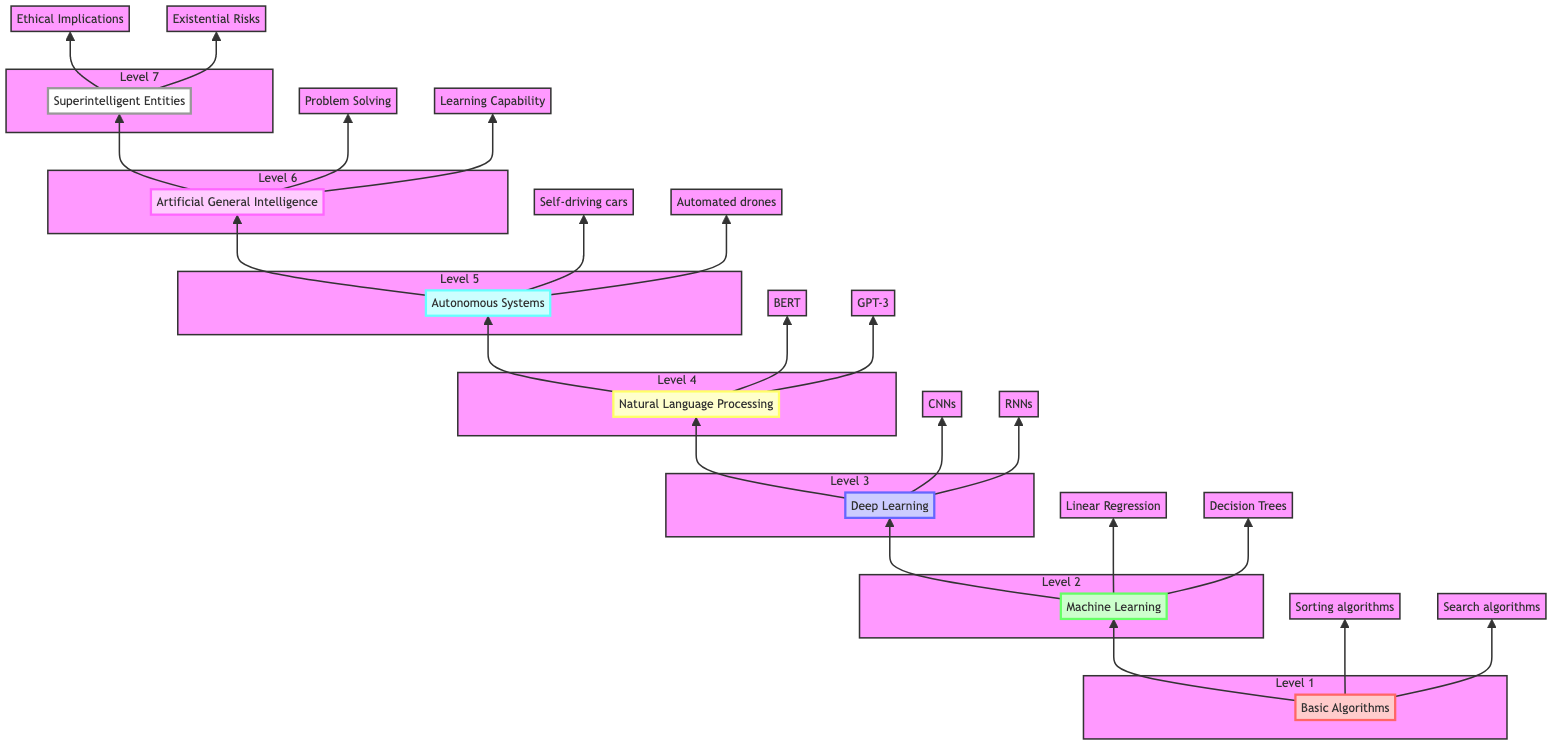What is the first node in the diagram? The first node, located at the bottom of the flow chart, is labeled "Basic Algorithms." It serves as the foundational starting point for the development of artificial intelligence concepts.
Answer: Basic Algorithms How many levels are represented in the diagram? The diagram contains a total of seven levels, each representing an advancement in the development of artificial intelligence technologies, from basic algorithms at the bottom to superintelligent entities at the top.
Answer: Seven What type of algorithms are associated with the "Basic Algorithms" node? Under the "Basic Algorithms" node, examples of the associated algorithms include "Sorting algorithms" and "Search algorithms," which illustrate the foundational techniques leading to more complex AI systems.
Answer: Sorting algorithms and Search algorithms Which node comes directly after "Deep Learning"? The node that comes directly after "Deep Learning" is "Natural Language Processing." This transition indicates a progression in complexity, where models become capable of understanding human language after mastering deep neural networks.
Answer: Natural Language Processing What are the core considerations associated with "Superintelligent Entities"? The core considerations associated with "Superintelligent Entities" include "Ethical Implications," "Existential Risks," and "Control Mechanisms." These concerns highlight important aspects we must manage when theorizing about entities that surpass human intelligence.
Answer: Ethical Implications, Existential Risks, and Control Mechanisms What is the role of "Autonomous Systems" in the flow diagram? "Autonomous Systems," positioned above "Natural Language Processing," signifies an advanced stage where machines perform tasks independently, showcasing a significant leap from processing language to executing tasks without human input.
Answer: Machines perform tasks without human intervention What is the relationship between "Machine Learning" and "Basic Algorithms"? "Machine Learning" is the next level that builds upon "Basic Algorithms," indicating that the learning systems depend on the foundational structures and algorithms established in this initial category to function effectively.
Answer: Machine Learning builds on Basic Algorithms What is the highest concept in the diagram? The highest concept in the diagram is "Superintelligent Entities," representing the theoretical peak of AI development, where entities possess intelligence significantly surpassing that of humans.
Answer: Superintelligent Entities Which example is given for "Deep Learning"? The examples given for "Deep Learning" include "Convolutional Neural Networks" and "Recurrent Neural Networks," which are specific applications that utilize deep learning techniques to address complex data patterns.
Answer: Convolutional Neural Networks and Recurrent Neural Networks 